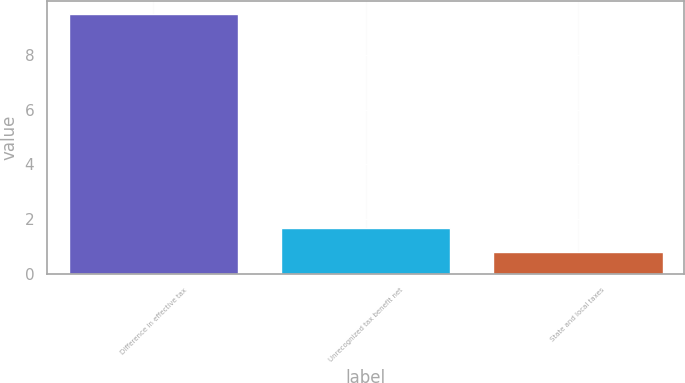<chart> <loc_0><loc_0><loc_500><loc_500><bar_chart><fcel>Difference in effective tax<fcel>Unrecognized tax benefit net<fcel>State and local taxes<nl><fcel>9.5<fcel>1.67<fcel>0.8<nl></chart> 